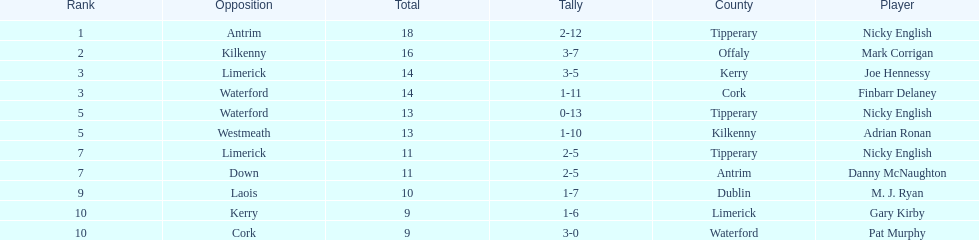Which player holds the highest ranking? Nicky English. 